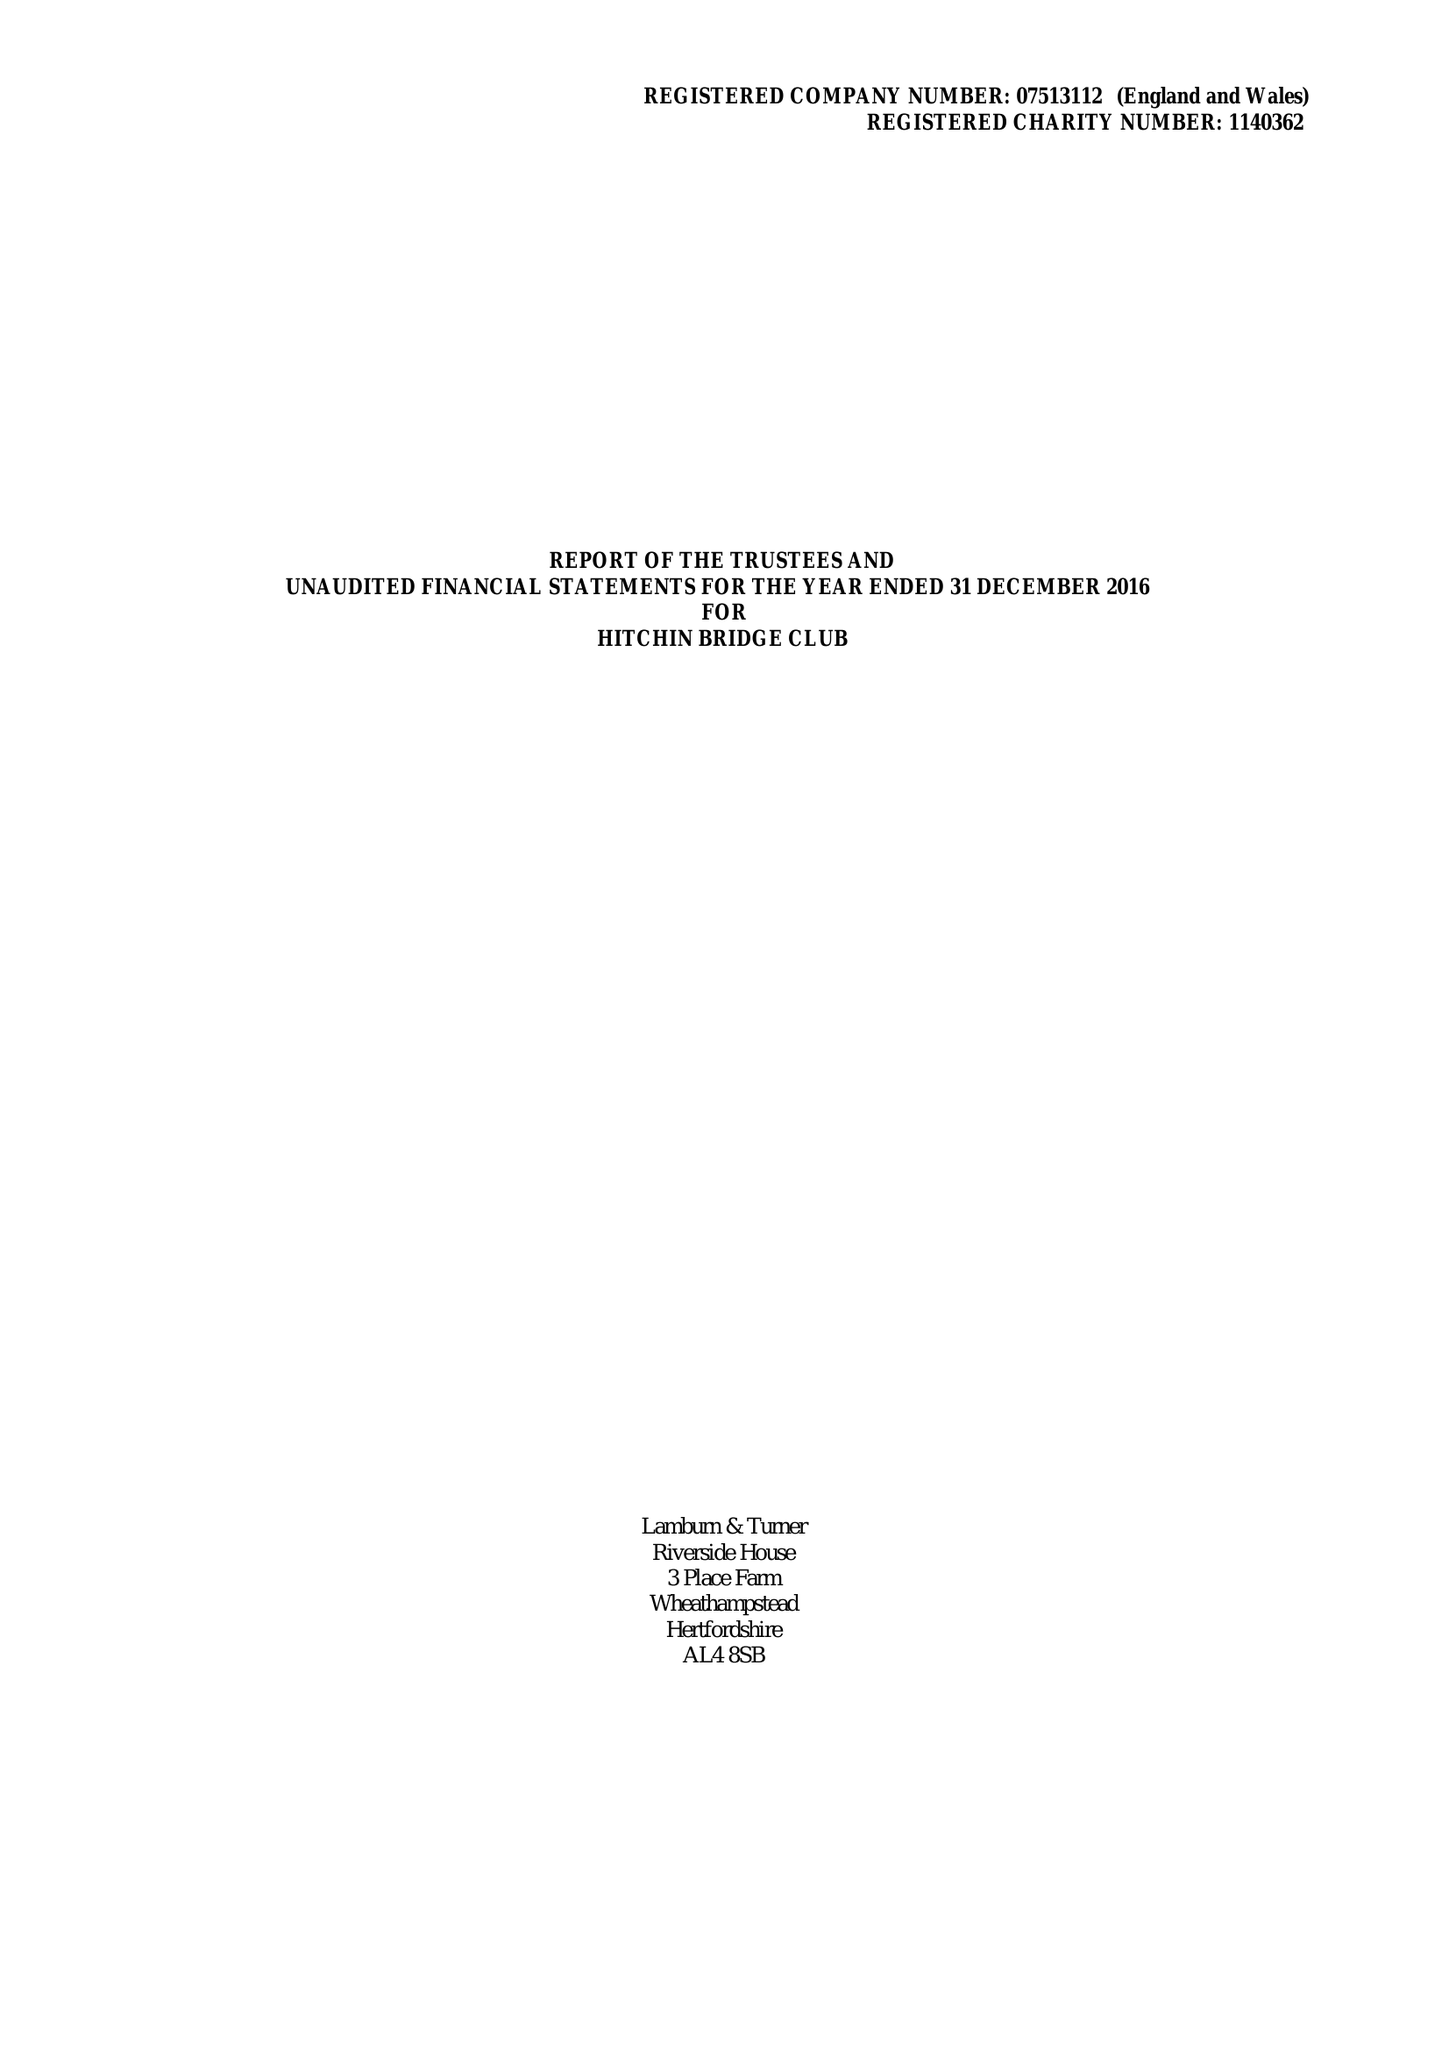What is the value for the address__post_town?
Answer the question using a single word or phrase. HITCHIN 